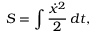<formula> <loc_0><loc_0><loc_500><loc_500>S = \int { \frac { { \dot { x } } ^ { 2 } } { 2 } } \, d t ,</formula> 